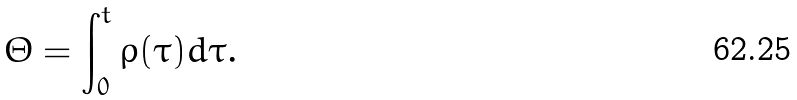Convert formula to latex. <formula><loc_0><loc_0><loc_500><loc_500>\Theta = \int _ { 0 } ^ { t } \rho ( \tau ) d \tau .</formula> 